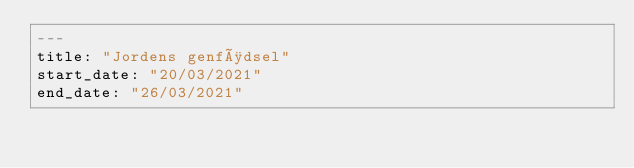Convert code to text. <code><loc_0><loc_0><loc_500><loc_500><_YAML_>---
title: "Jordens genfødsel"
start_date: "20/03/2021"
end_date: "26/03/2021"</code> 